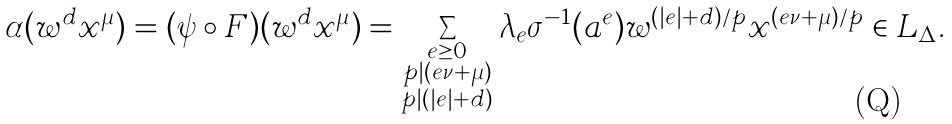Convert formula to latex. <formula><loc_0><loc_0><loc_500><loc_500>\alpha ( w ^ { d } x ^ { \mu } ) = ( \psi \circ F ) ( w ^ { d } x ^ { \mu } ) = \sum _ { \substack { e \geq 0 \\ p | ( e \nu + \mu ) \\ p | ( | e | + d ) } } \lambda _ { e } \sigma ^ { - 1 } ( a ^ { e } ) w ^ { ( | e | + d ) / p } x ^ { ( e \nu + \mu ) / p } \in L _ { \Delta } .</formula> 